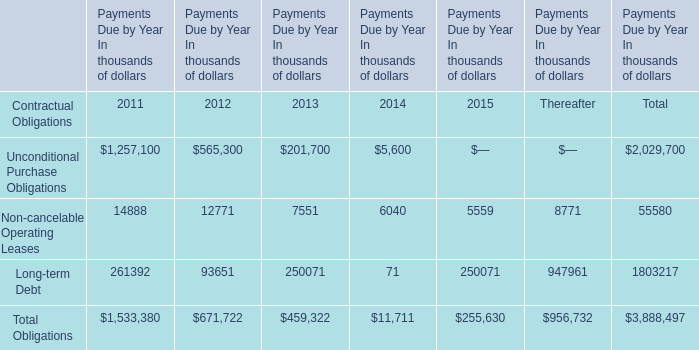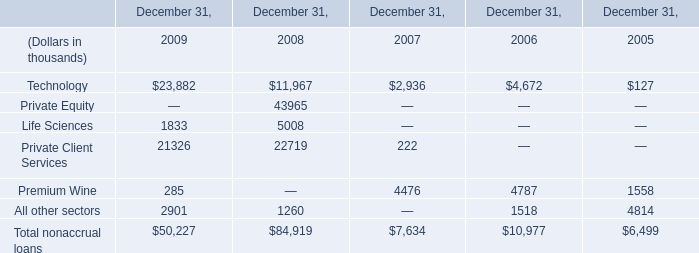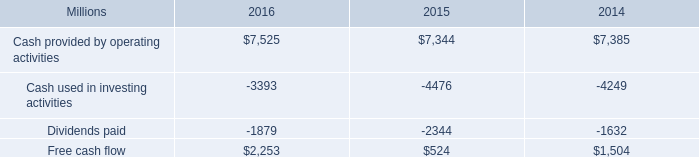What is the sum of Premium Wine in 2007 and Non-cancelable Operating Leases in 2013? (in thousand) 
Computations: (4476 + 7551)
Answer: 12027.0. 